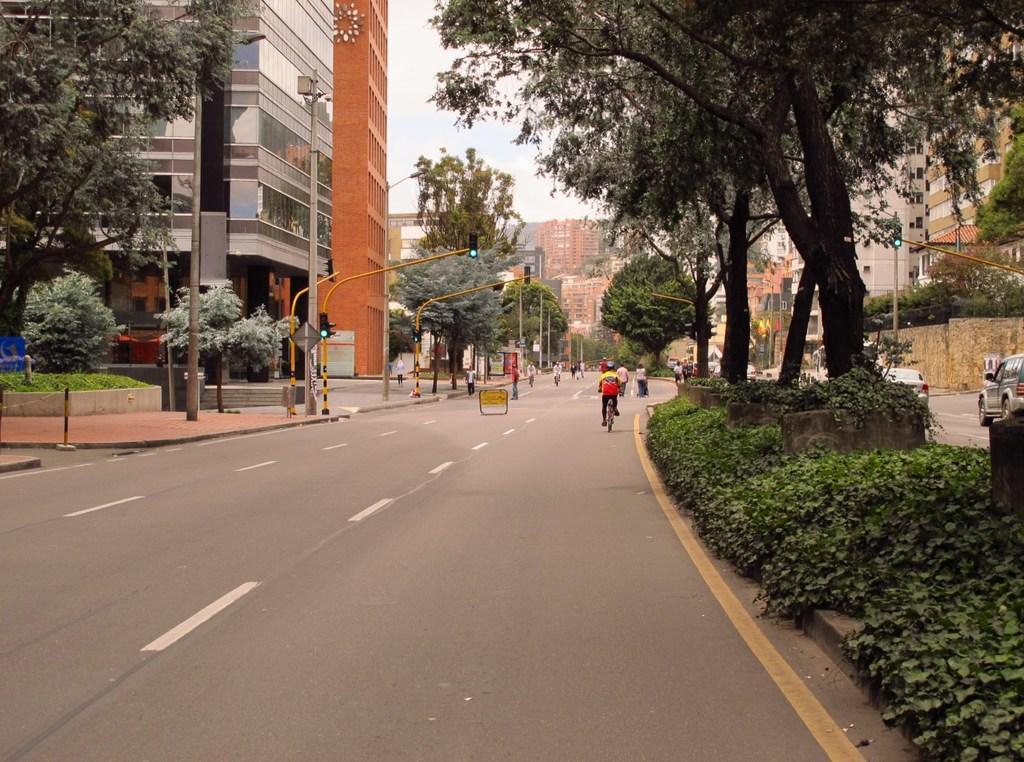Describe this image in one or two sentences. In this image there is a person riding the bicycle on the road. Few people are on the road. Right side few vehicles are on the road. There are few plants and trees are on the pavement. Left side there are few poles having traffic lights attached to it. Few street lights are on the pavement. Background there are few trees and buildings. Top of the image there is sky. 